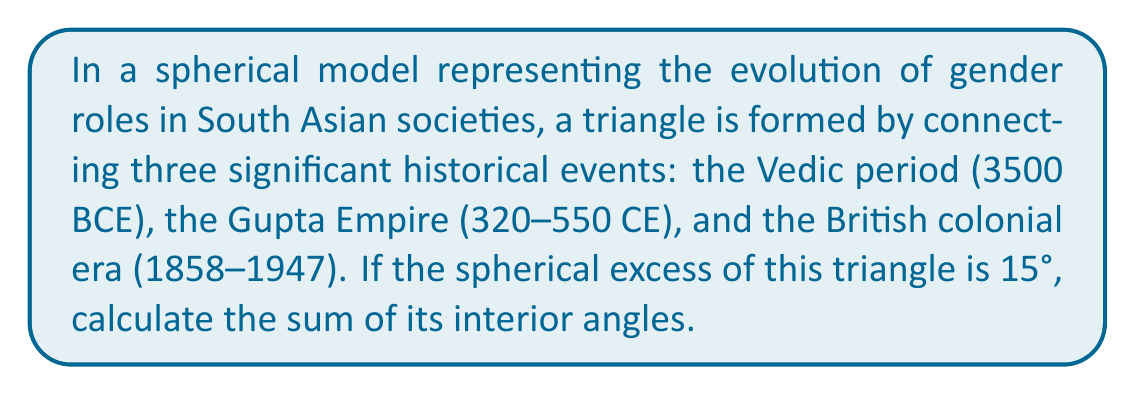Teach me how to tackle this problem. To solve this problem, we need to understand the concept of spherical excess and its relation to the angle sum of triangles on a sphere. Let's break it down step-by-step:

1) In Euclidean geometry, the sum of angles in a triangle is always 180°. However, on a spherical surface, this sum is always greater than 180°.

2) The difference between the sum of angles in a spherical triangle and 180° is called the spherical excess, denoted as $E$.

3) The formula relating the angle sum of a spherical triangle to its spherical excess is:

   $$\text{Angle Sum} = 180° + E$$

   Where $E$ is the spherical excess.

4) In this problem, we're given that the spherical excess $E = 15°$.

5) Substituting this into our formula:

   $$\text{Angle Sum} = 180° + 15°$$

6) Simplifying:

   $$\text{Angle Sum} = 195°$$

This result shows how the non-Euclidean nature of spherical geometry affects the properties of triangles, much like how societal changes over time can alter the traditional structures and roles in South Asian cultures.
Answer: 195° 